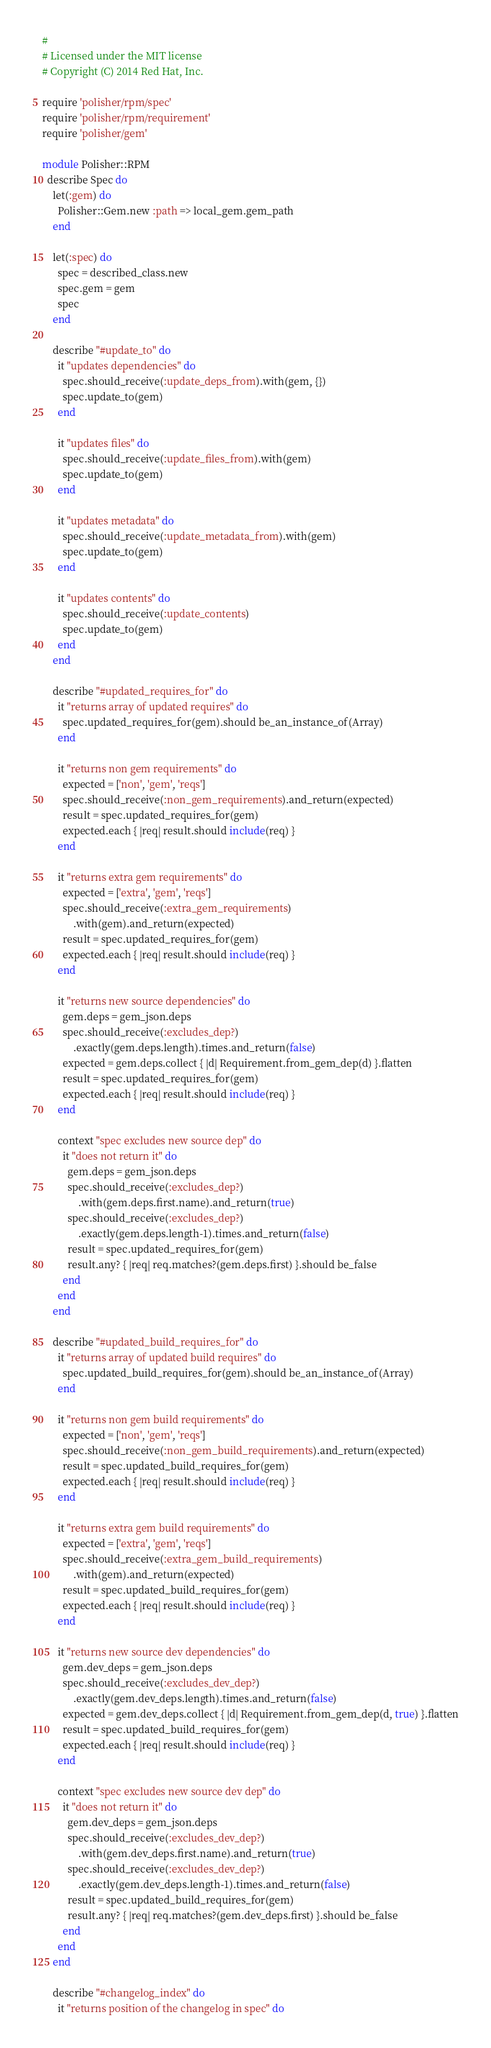<code> <loc_0><loc_0><loc_500><loc_500><_Ruby_>#
# Licensed under the MIT license
# Copyright (C) 2014 Red Hat, Inc.

require 'polisher/rpm/spec'
require 'polisher/rpm/requirement'
require 'polisher/gem'

module Polisher::RPM
  describe Spec do
    let(:gem) do
      Polisher::Gem.new :path => local_gem.gem_path
    end

    let(:spec) do
      spec = described_class.new 
      spec.gem = gem
      spec
    end

    describe "#update_to" do
      it "updates dependencies" do
        spec.should_receive(:update_deps_from).with(gem, {})
        spec.update_to(gem)
      end

      it "updates files" do
        spec.should_receive(:update_files_from).with(gem)
        spec.update_to(gem)
      end

      it "updates metadata" do
        spec.should_receive(:update_metadata_from).with(gem)
        spec.update_to(gem)
      end

      it "updates contents" do
        spec.should_receive(:update_contents)
        spec.update_to(gem)
      end
    end

    describe "#updated_requires_for" do
      it "returns array of updated requires" do
        spec.updated_requires_for(gem).should be_an_instance_of(Array)
      end

      it "returns non gem requirements" do
        expected = ['non', 'gem', 'reqs']
        spec.should_receive(:non_gem_requirements).and_return(expected)
        result = spec.updated_requires_for(gem)
        expected.each { |req| result.should include(req) }
      end

      it "returns extra gem requirements" do
        expected = ['extra', 'gem', 'reqs']
        spec.should_receive(:extra_gem_requirements)
            .with(gem).and_return(expected)
        result = spec.updated_requires_for(gem)
        expected.each { |req| result.should include(req) }
      end

      it "returns new source dependencies" do
        gem.deps = gem_json.deps
        spec.should_receive(:excludes_dep?)
            .exactly(gem.deps.length).times.and_return(false)
        expected = gem.deps.collect { |d| Requirement.from_gem_dep(d) }.flatten
        result = spec.updated_requires_for(gem)
        expected.each { |req| result.should include(req) }
      end

      context "spec excludes new source dep" do
        it "does not return it" do
          gem.deps = gem_json.deps
          spec.should_receive(:excludes_dep?)
              .with(gem.deps.first.name).and_return(true)
          spec.should_receive(:excludes_dep?)
              .exactly(gem.deps.length-1).times.and_return(false)
          result = spec.updated_requires_for(gem)
          result.any? { |req| req.matches?(gem.deps.first) }.should be_false
        end
      end
    end

    describe "#updated_build_requires_for" do
      it "returns array of updated build requires" do
        spec.updated_build_requires_for(gem).should be_an_instance_of(Array)
      end

      it "returns non gem build requirements" do
        expected = ['non', 'gem', 'reqs']
        spec.should_receive(:non_gem_build_requirements).and_return(expected)
        result = spec.updated_build_requires_for(gem)
        expected.each { |req| result.should include(req) }
      end

      it "returns extra gem build requirements" do
        expected = ['extra', 'gem', 'reqs']
        spec.should_receive(:extra_gem_build_requirements)
            .with(gem).and_return(expected)
        result = spec.updated_build_requires_for(gem)
        expected.each { |req| result.should include(req) }
      end

      it "returns new source dev dependencies" do
        gem.dev_deps = gem_json.deps
        spec.should_receive(:excludes_dev_dep?)
            .exactly(gem.dev_deps.length).times.and_return(false)
        expected = gem.dev_deps.collect { |d| Requirement.from_gem_dep(d, true) }.flatten
        result = spec.updated_build_requires_for(gem)
        expected.each { |req| result.should include(req) }
      end

      context "spec excludes new source dev dep" do
        it "does not return it" do
          gem.dev_deps = gem_json.deps
          spec.should_receive(:excludes_dev_dep?)
              .with(gem.dev_deps.first.name).and_return(true)
          spec.should_receive(:excludes_dev_dep?)
              .exactly(gem.dev_deps.length-1).times.and_return(false)
          result = spec.updated_build_requires_for(gem)
          result.any? { |req| req.matches?(gem.dev_deps.first) }.should be_false
        end
      end
    end

    describe "#changelog_index" do
      it "returns position of the changelog in spec" do</code> 